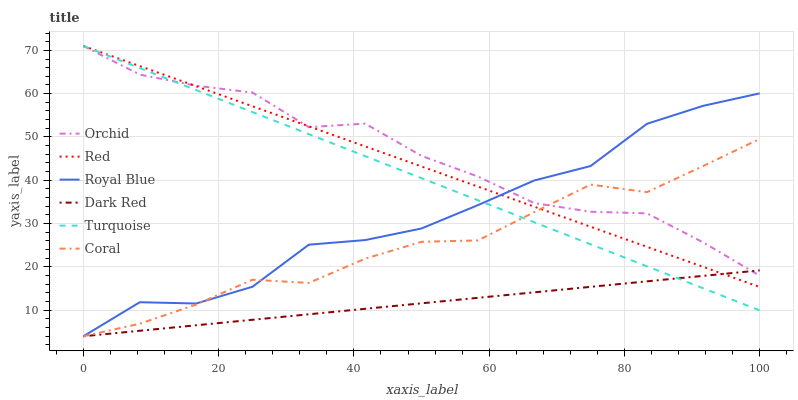Does Dark Red have the minimum area under the curve?
Answer yes or no. Yes. Does Orchid have the maximum area under the curve?
Answer yes or no. Yes. Does Coral have the minimum area under the curve?
Answer yes or no. No. Does Coral have the maximum area under the curve?
Answer yes or no. No. Is Dark Red the smoothest?
Answer yes or no. Yes. Is Royal Blue the roughest?
Answer yes or no. Yes. Is Coral the smoothest?
Answer yes or no. No. Is Coral the roughest?
Answer yes or no. No. Does Dark Red have the lowest value?
Answer yes or no. Yes. Does Red have the lowest value?
Answer yes or no. No. Does Orchid have the highest value?
Answer yes or no. Yes. Does Coral have the highest value?
Answer yes or no. No. Does Turquoise intersect Royal Blue?
Answer yes or no. Yes. Is Turquoise less than Royal Blue?
Answer yes or no. No. Is Turquoise greater than Royal Blue?
Answer yes or no. No. 